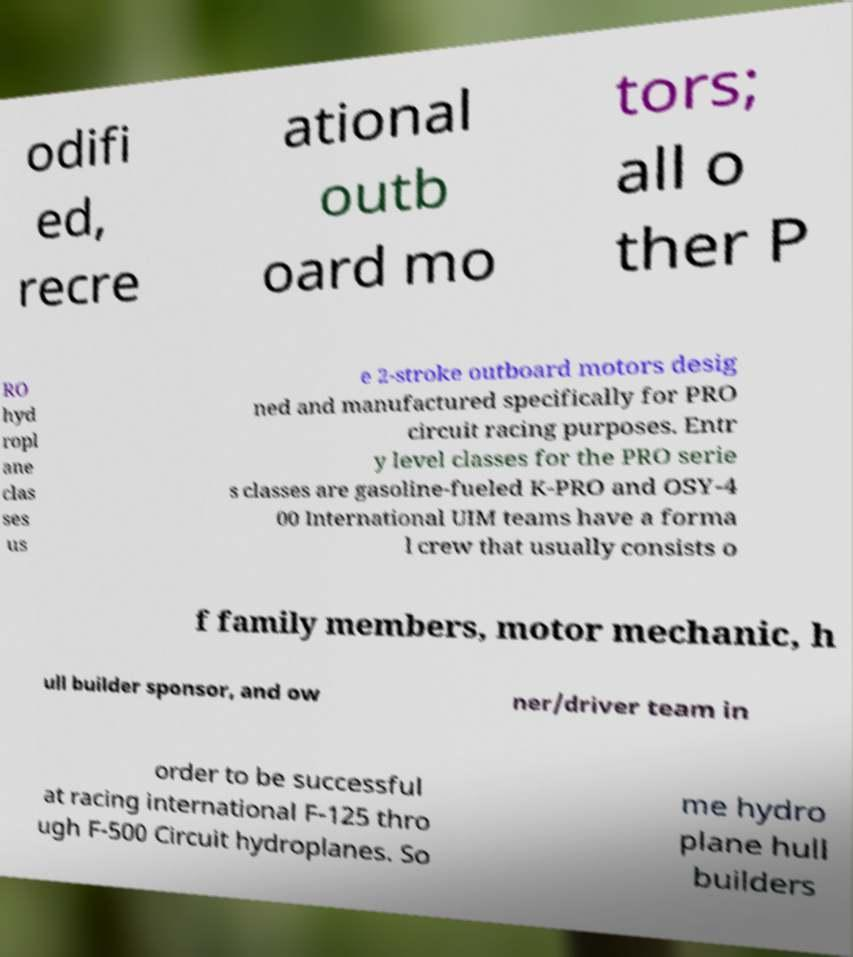Could you extract and type out the text from this image? odifi ed, recre ational outb oard mo tors; all o ther P RO hyd ropl ane clas ses us e 2-stroke outboard motors desig ned and manufactured specifically for PRO circuit racing purposes. Entr y level classes for the PRO serie s classes are gasoline-fueled K-PRO and OSY-4 00 International UIM teams have a forma l crew that usually consists o f family members, motor mechanic, h ull builder sponsor, and ow ner/driver team in order to be successful at racing international F-125 thro ugh F-500 Circuit hydroplanes. So me hydro plane hull builders 